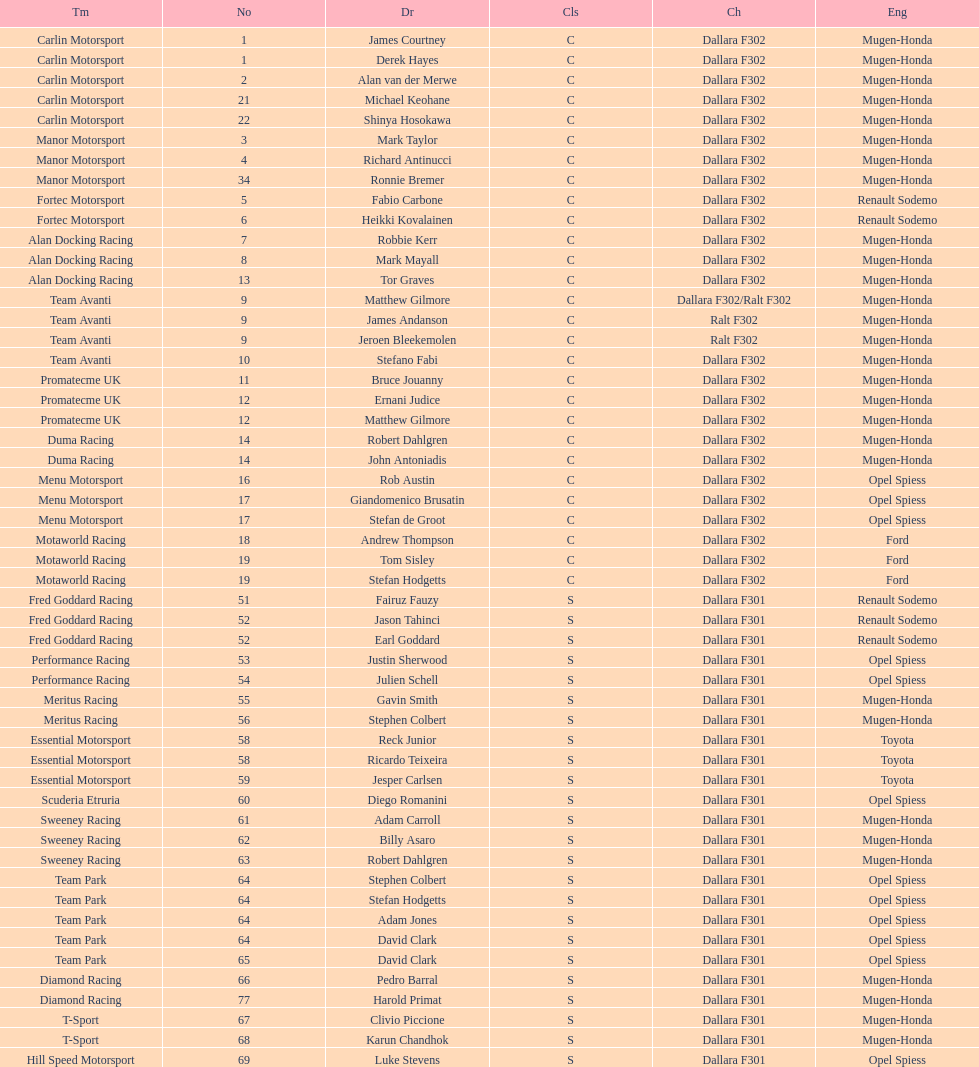How many teams featured no less than two drivers this season? 17. 